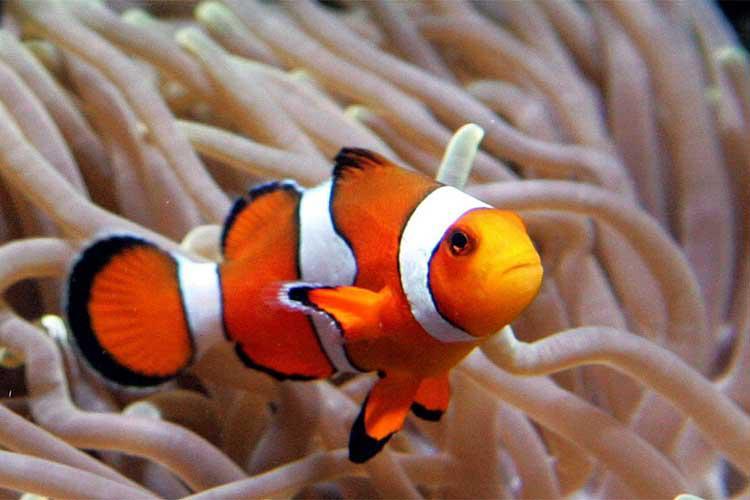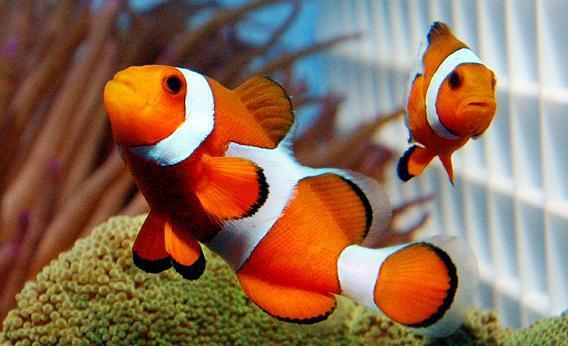The first image is the image on the left, the second image is the image on the right. Examine the images to the left and right. Is the description "Each image contains the same number of clown fish swimming among anemone tendrils." accurate? Answer yes or no. No. The first image is the image on the left, the second image is the image on the right. Evaluate the accuracy of this statement regarding the images: "One single fish is swimming in the image on the right.". Is it true? Answer yes or no. No. The first image is the image on the left, the second image is the image on the right. Examine the images to the left and right. Is the description "Three clown fish are shown, in total." accurate? Answer yes or no. Yes. 